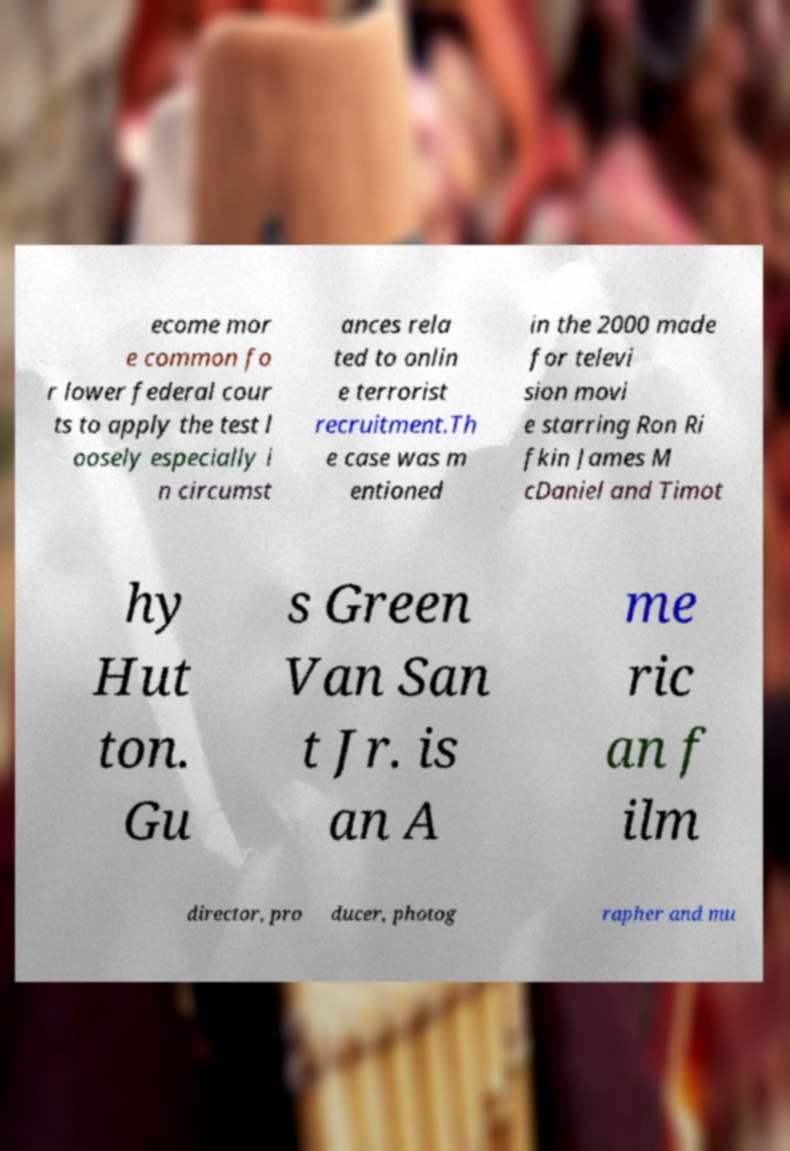There's text embedded in this image that I need extracted. Can you transcribe it verbatim? ecome mor e common fo r lower federal cour ts to apply the test l oosely especially i n circumst ances rela ted to onlin e terrorist recruitment.Th e case was m entioned in the 2000 made for televi sion movi e starring Ron Ri fkin James M cDaniel and Timot hy Hut ton. Gu s Green Van San t Jr. is an A me ric an f ilm director, pro ducer, photog rapher and mu 